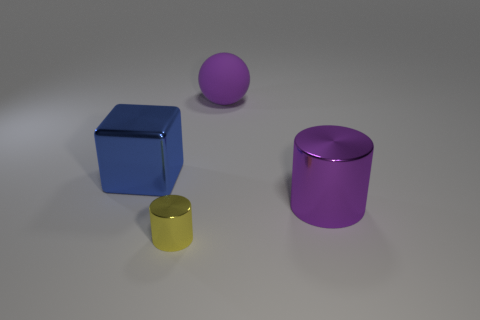Add 1 yellow objects. How many objects exist? 5 Subtract all purple cylinders. How many cylinders are left? 1 Subtract all green cylinders. How many purple cubes are left? 0 Subtract all spheres. How many objects are left? 3 Subtract 1 blocks. How many blocks are left? 0 Subtract all red cylinders. Subtract all green cubes. How many cylinders are left? 2 Subtract all large matte spheres. Subtract all tiny yellow cylinders. How many objects are left? 2 Add 3 big cylinders. How many big cylinders are left? 4 Add 1 big yellow shiny balls. How many big yellow shiny balls exist? 1 Subtract 0 red cubes. How many objects are left? 4 